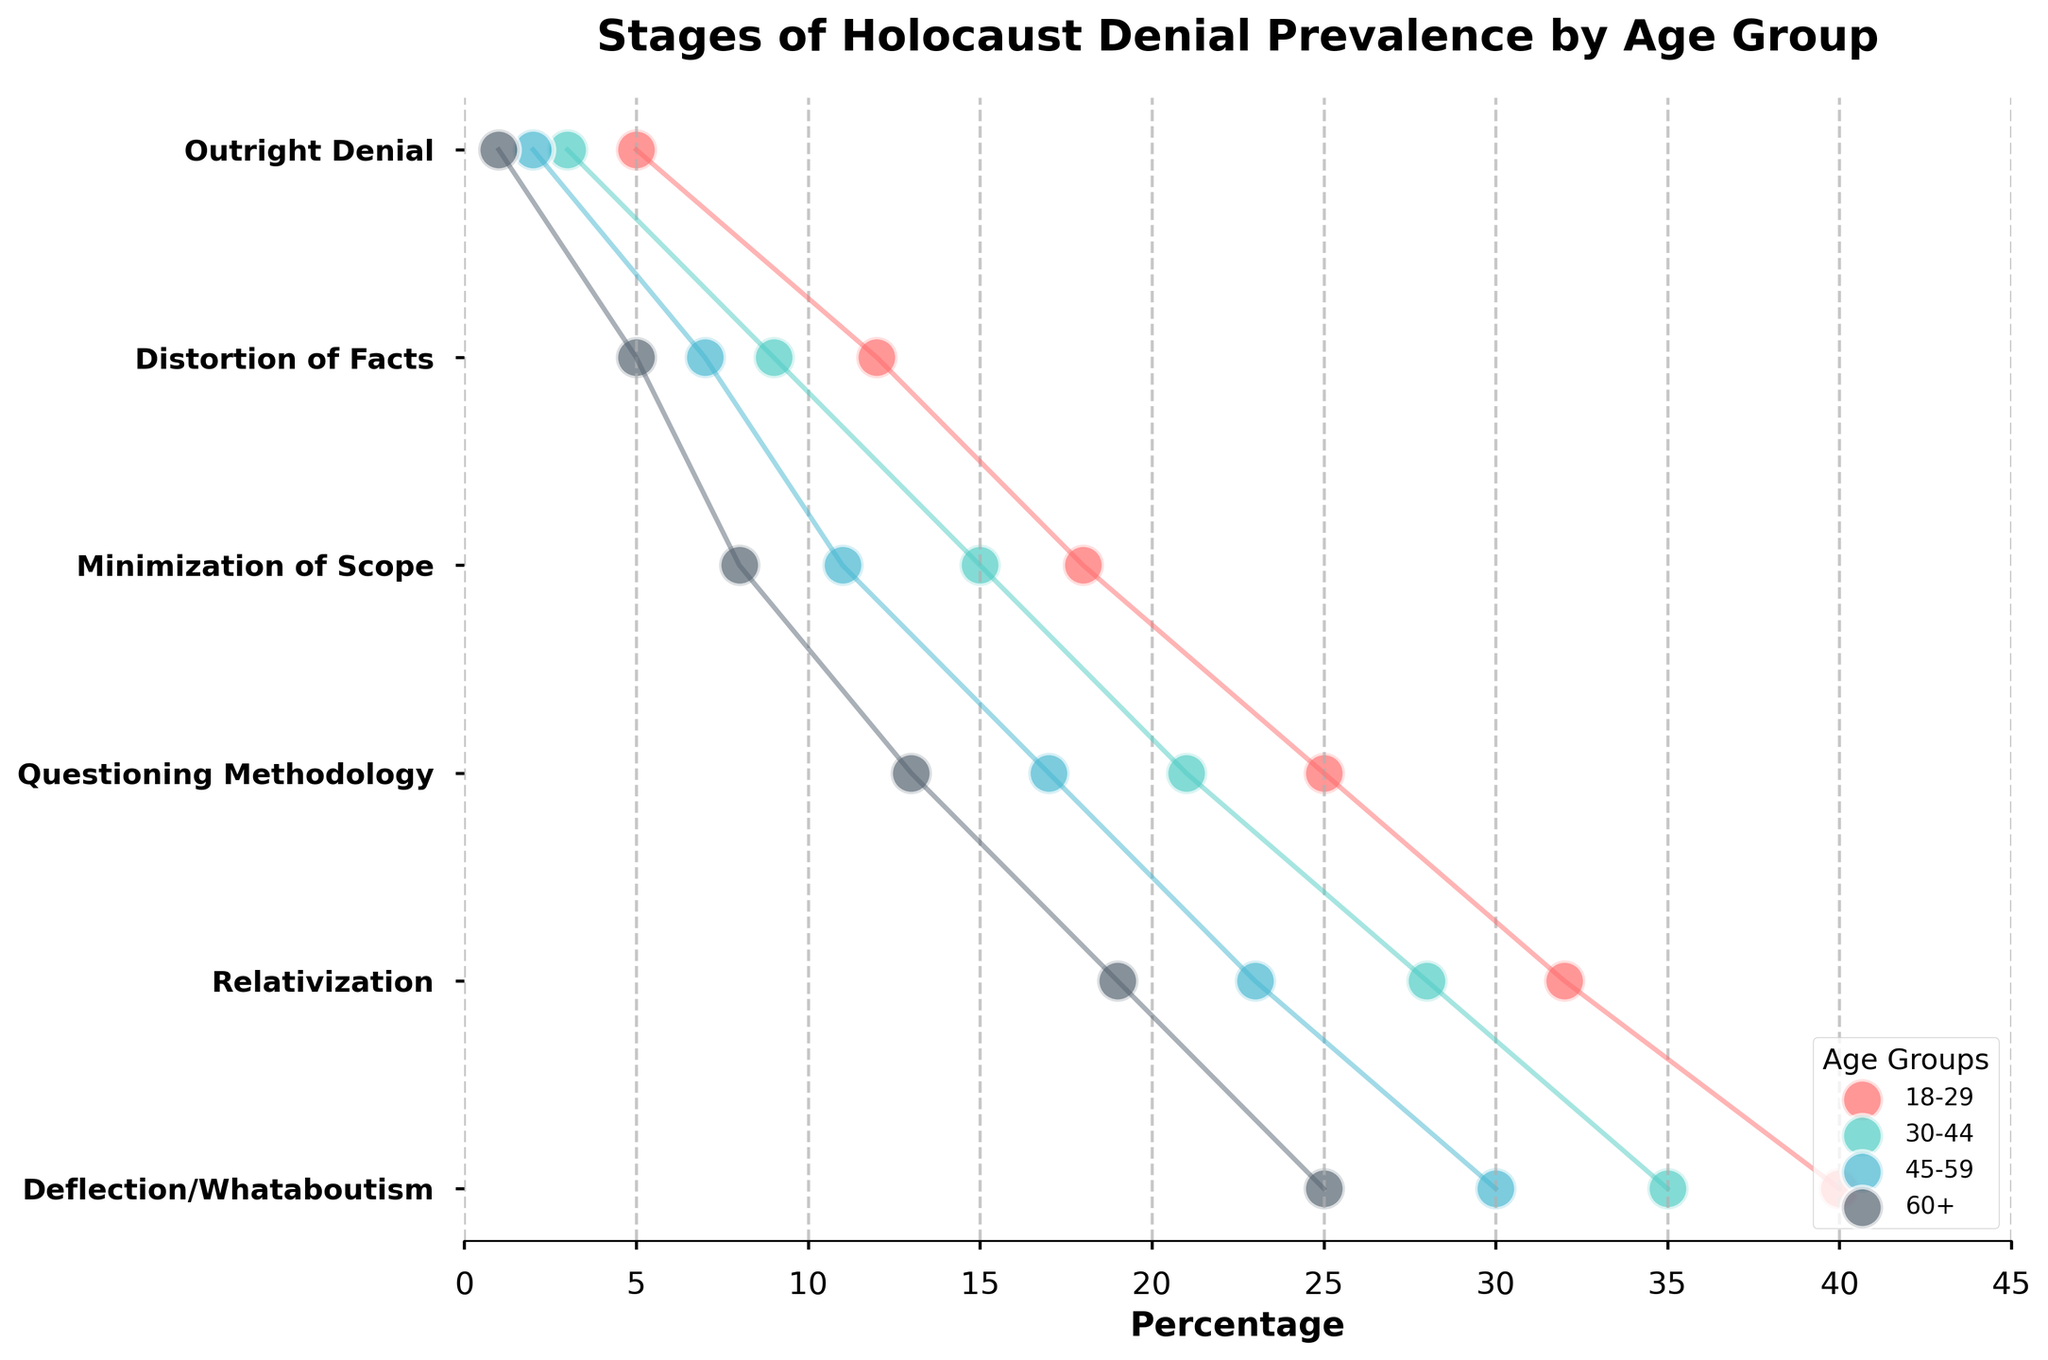what is the title of the chart? The title is located at the top of the chart. It provides information about the overall subject of the chart. We can see from the visual that the chart's title is 'Stages of Holocaust Denial Prevalence by Age Group'.
Answer: Stages of Holocaust Denial Prevalence by Age Group Which age group has the highest percentage of 'Outright Denial'? To find which age group has the highest 'Outright Denial' percentage, we look for the age group with the maximum value for this particular stage. The 18-29 age group has the highest percentage at 5%.
Answer: 18-29 How does the percentage of 'Relativization' compare between the 30-44 and 60+ age groups? To compare, observe the percentages for 'Relativization' in both age groups. The 30-44 age group has 28%, whereas the 60+ age group has 19%.
Answer: 30-44 is higher What is the average percentage of 'Questioning Methodology' across all age groups? Calculate the average by summing up the percentages for 'Questioning Methodology' across all age groups and then dividing by the number of age groups: (25% + 21% + 17% + 13%) / 4 = 19%.
Answer: 19% Which stage shows the largest difference in percentage between the 18-29 and 45-59 age groups? To identify this, check the differences in percentages for each stage between these age groups. 'Deflection/Whataboutism' shows the highest difference, with 40% for 18-29 and 30% for 45-59, giving a difference of 10%.
Answer: Deflection/Whataboutism For the stage 'Minimization of Scope', what is the combined percentage for all age groups? To find the combined percentage, add the values for all age groups for 'Minimization of Scope': 18% + 15% + 11% + 8% = 52%.
Answer: 52% In terms of 'Distortion of Facts', which age group has the second-lowest percentage? Looking at the percentages for 'Distortion of Facts', the age group with the second-lowest percentage is 45-59 with 7% (the lowest is 60+ with 5%).
Answer: 45-59 How does the trend of 'Deflection/Whataboutism' change across the age groups? Observing the trend, 'Deflection/Whataboutism' decreases steadily from left to right across the age groups: 40% (18-29), 35% (30-44), 30% (45-59), and 25% (60+). It shows a consistent downward trend.
Answer: Decreases What is the median percentage of 'Minimization of Scope' across all age groups? To find the median percentage, list the values for 'Minimization of Scope' in order: 8%, 11%, 15%, 18%. The median is the average of the two middle numbers: (11% + 15%) / 2 = 13%.
Answer: 13% 